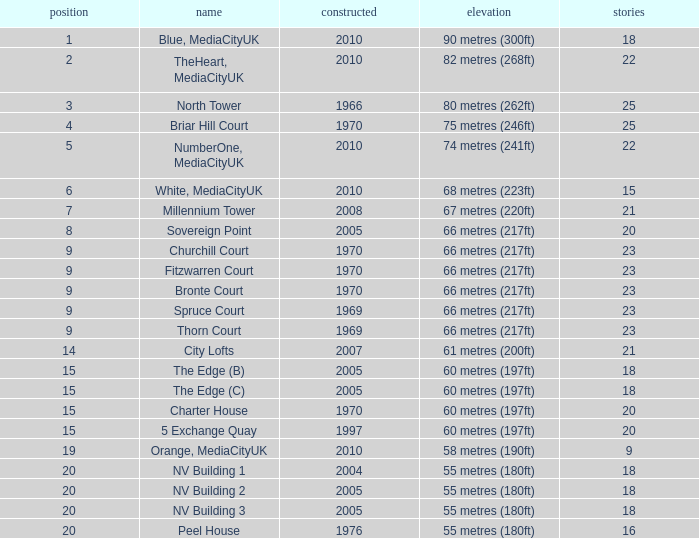What is Height, when Rank is less than 20, when Floors is greater than 9, when Built is 2005, and when Name is The Edge (C)? 60 metres (197ft). 